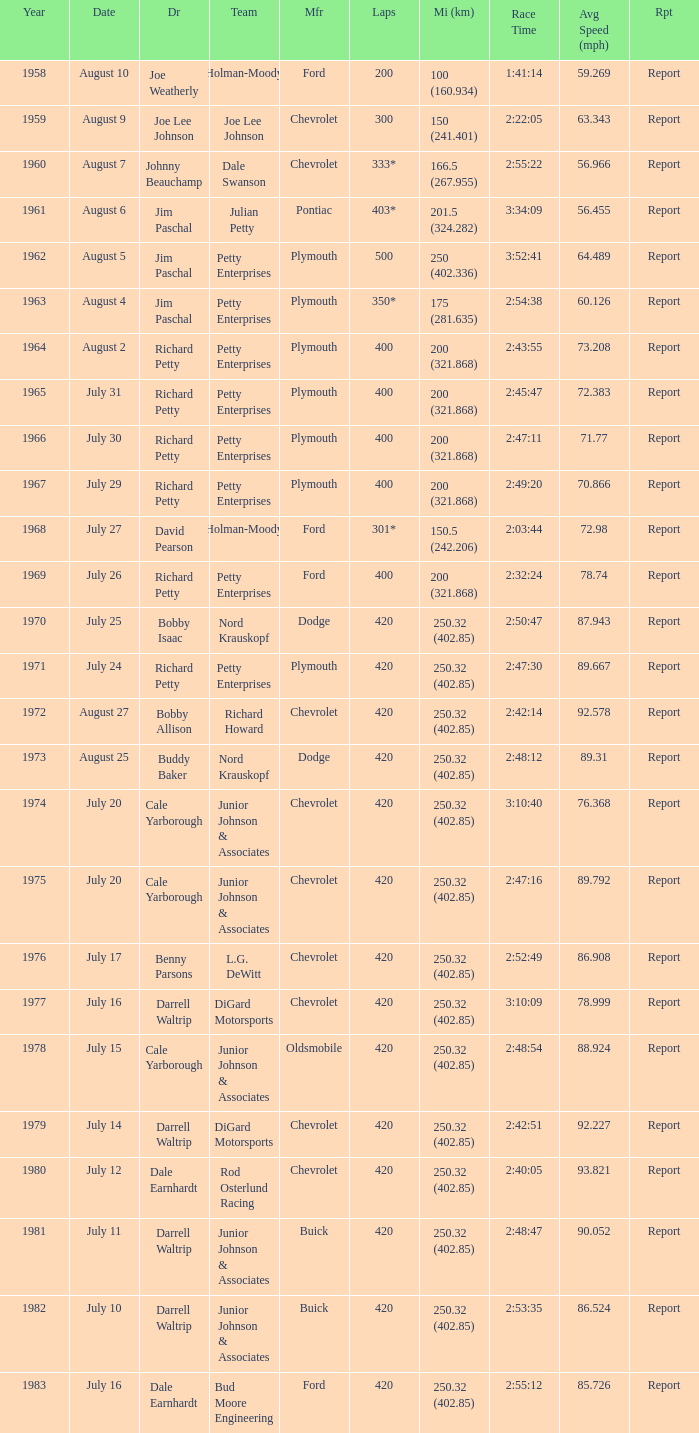924 mph? 1.0. 